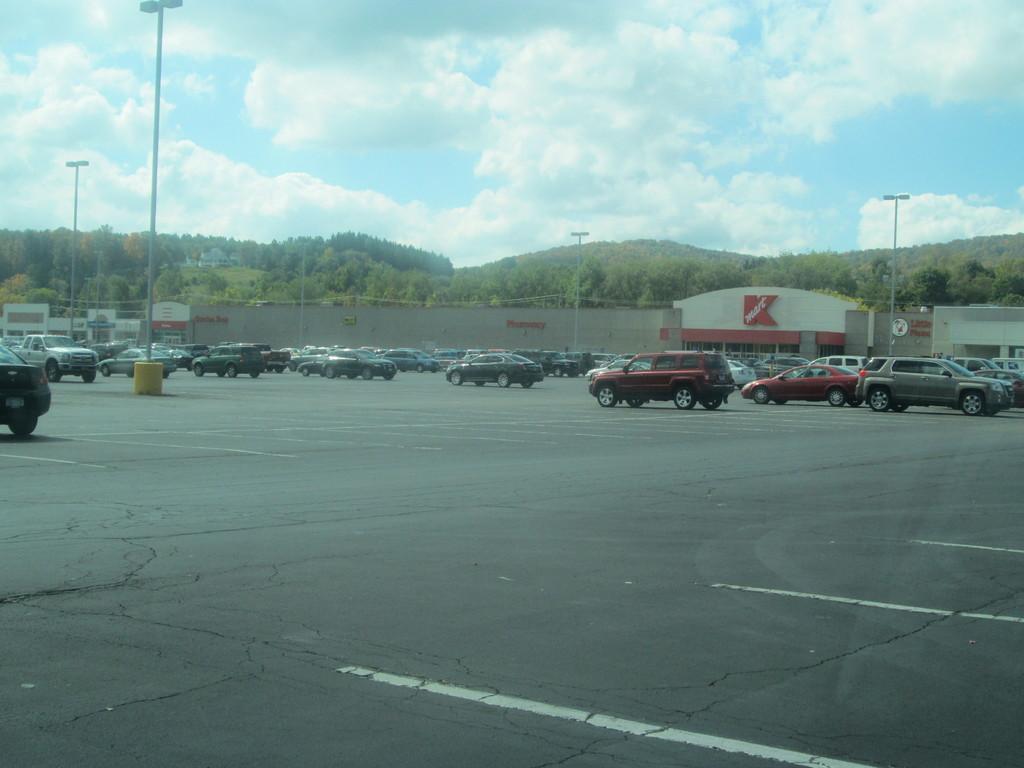Please provide a concise description of this image. At the bottom of the image there is a road. On the road there are many cars and also there are poles with lights. Behind them there are stores. Behind the stores there are trees. At the top of the image there is a sky with clouds. 